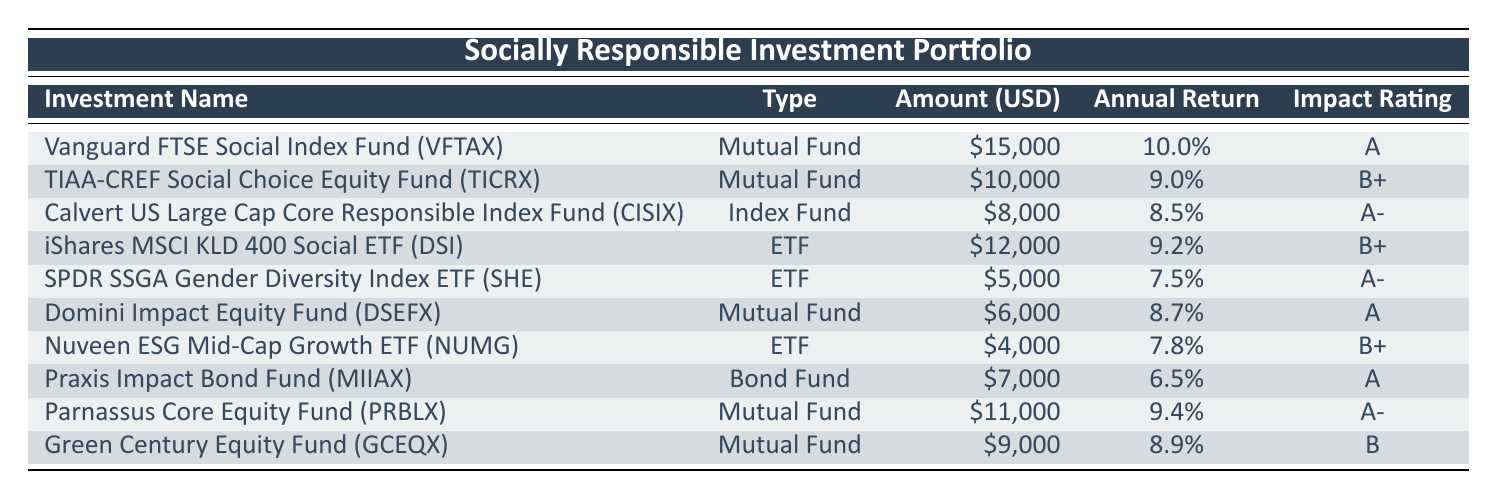What is the total amount invested in all the Mutual Funds? The Mutual Funds listed are: Vanguard FTSE Social Index Fund (15000), TIAA-CREF Social Choice Equity Fund (10000), Calvert US Large Cap Core Responsible Index Fund (8000), Domini Impact Equity Fund (6000), Parnassus Core Equity Fund (11000), and Green Century Equity Fund (9000). Adding these together gives 15000 + 10000 + 8000 + 6000 + 11000 + 9000 = 59000.
Answer: 59000 Which investment has the highest Annual Return? Scanning the Annual Return column, the highest value is 10.0%, corresponding to the Vanguard FTSE Social Index Fund (VFTAX).
Answer: Vanguard FTSE Social Index Fund (VFTAX) Are there any ETFs with a Social Impact Rating of A? Checking the Social Impact Ratings, only one ETF, the SPDR SSGA Gender Diversity Index ETF, is rated A.
Answer: No What is the average Annual Return of all the investments? The Annual Returns are 10, 9, 8.5, 9.2, 7.5, 8.7, 7.8, 6.5, 9.4, and 8.9. Adding them gives 10 + 9 + 8.5 + 9.2 + 7.5 + 8.7 + 7.8 + 6.5 + 9.4 + 8.9 = 78.8. Then divide by the number of investments (10): 78.8 / 10 = 7.88.
Answer: 7.88 Which investment type has the lowest amount invested? Looking at the Amount Invested column, the Nuveen ESG Mid-Cap Growth ETF has the lowest investment amount of 4000.
Answer: ETF How many investments have a Social Impact Rating of B+? From the table, the TIAA-CREF Social Choice Equity Fund (B+) and iShares MSCI KLD 400 Social ETF (B+) both have this rating. Thus, there are two investments with a B+ rating.
Answer: 2 What is the difference in amount invested between the highest and lowest investment? The highest amount invested is 15000 (Vanguard FTSE Social Index Fund), and the lowest is 4000 (Nuveen ESG Mid-Cap Growth ETF). The difference is 15000 - 4000 = 11000.
Answer: 11000 Is there a Bond Fund in the portfolio? Yes, the Praxis Impact Bond Fund is listed under the Bond Fund type.
Answer: Yes 